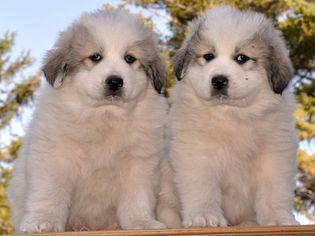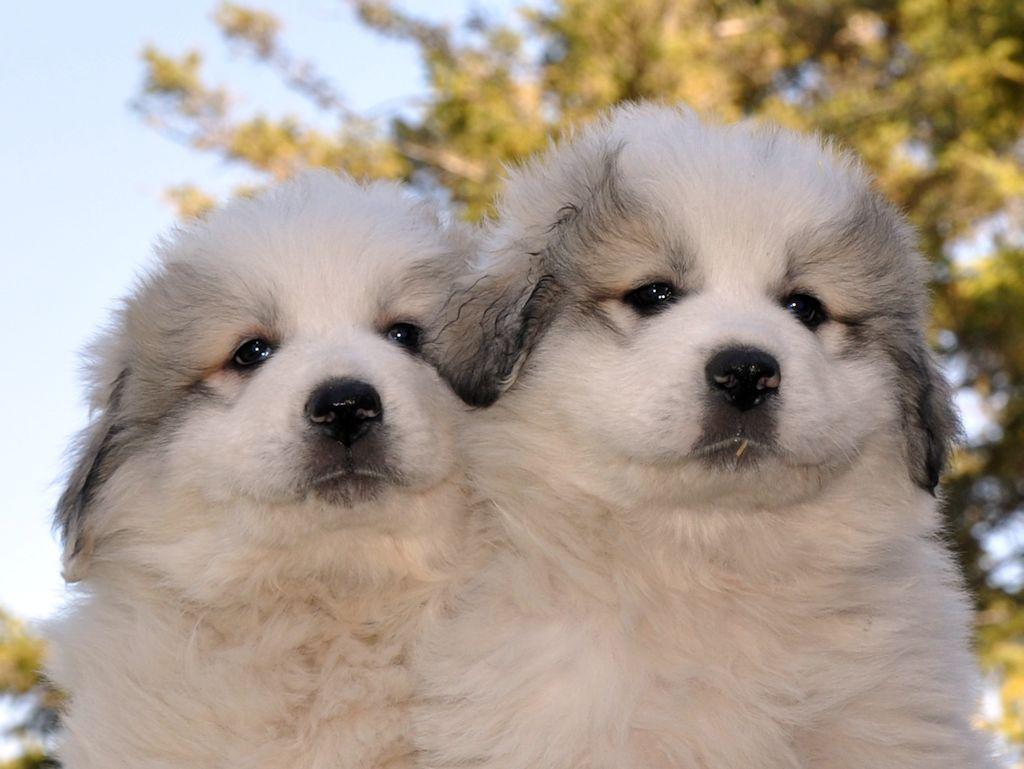The first image is the image on the left, the second image is the image on the right. Assess this claim about the two images: "There are two dogs together in front of a visible sky in each image.". Correct or not? Answer yes or no. Yes. The first image is the image on the left, the second image is the image on the right. Examine the images to the left and right. Is the description "The sky is visible in both of the images." accurate? Answer yes or no. Yes. 